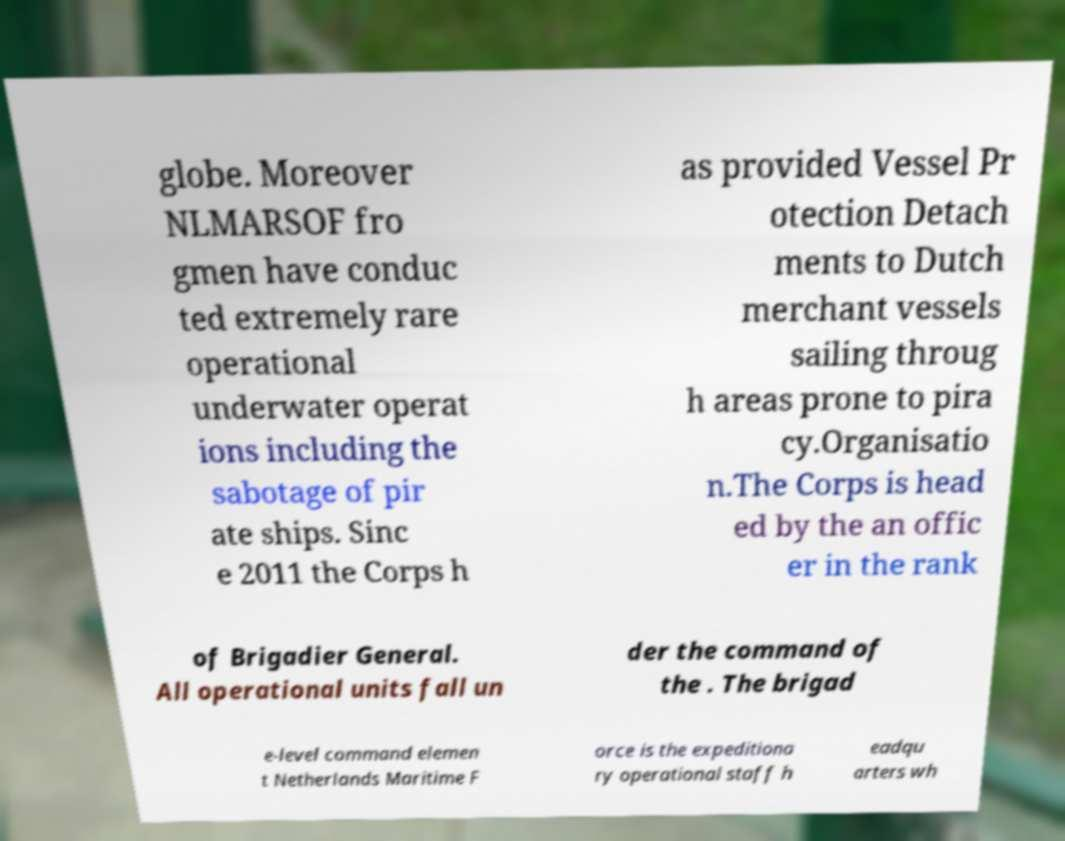For documentation purposes, I need the text within this image transcribed. Could you provide that? globe. Moreover NLMARSOF fro gmen have conduc ted extremely rare operational underwater operat ions including the sabotage of pir ate ships. Sinc e 2011 the Corps h as provided Vessel Pr otection Detach ments to Dutch merchant vessels sailing throug h areas prone to pira cy.Organisatio n.The Corps is head ed by the an offic er in the rank of Brigadier General. All operational units fall un der the command of the . The brigad e-level command elemen t Netherlands Maritime F orce is the expeditiona ry operational staff h eadqu arters wh 